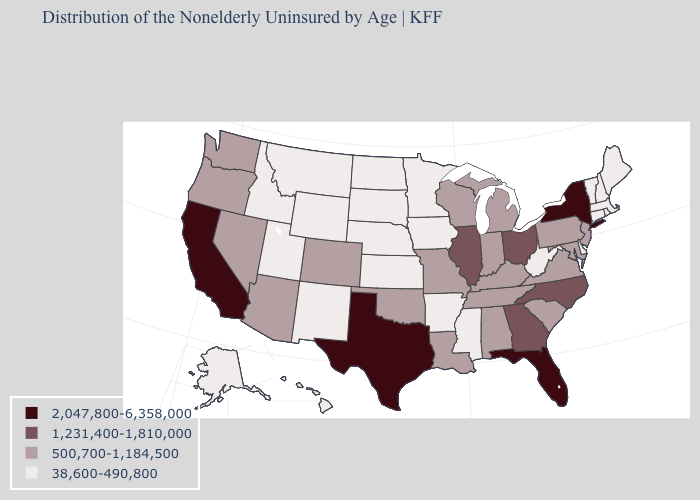Which states have the lowest value in the South?
Answer briefly. Arkansas, Delaware, Mississippi, West Virginia. Name the states that have a value in the range 500,700-1,184,500?
Quick response, please. Alabama, Arizona, Colorado, Indiana, Kentucky, Louisiana, Maryland, Michigan, Missouri, Nevada, New Jersey, Oklahoma, Oregon, Pennsylvania, South Carolina, Tennessee, Virginia, Washington, Wisconsin. Which states have the lowest value in the South?
Concise answer only. Arkansas, Delaware, Mississippi, West Virginia. What is the value of Washington?
Quick response, please. 500,700-1,184,500. What is the highest value in the West ?
Short answer required. 2,047,800-6,358,000. What is the value of Pennsylvania?
Concise answer only. 500,700-1,184,500. Does the first symbol in the legend represent the smallest category?
Give a very brief answer. No. Name the states that have a value in the range 1,231,400-1,810,000?
Answer briefly. Georgia, Illinois, North Carolina, Ohio. Name the states that have a value in the range 2,047,800-6,358,000?
Be succinct. California, Florida, New York, Texas. What is the highest value in the South ?
Keep it brief. 2,047,800-6,358,000. Does Colorado have the same value as Oregon?
Be succinct. Yes. Does North Carolina have a higher value than Oklahoma?
Quick response, please. Yes. Among the states that border Arkansas , does Texas have the highest value?
Be succinct. Yes. Among the states that border Rhode Island , which have the lowest value?
Give a very brief answer. Connecticut, Massachusetts. What is the highest value in the USA?
Answer briefly. 2,047,800-6,358,000. 